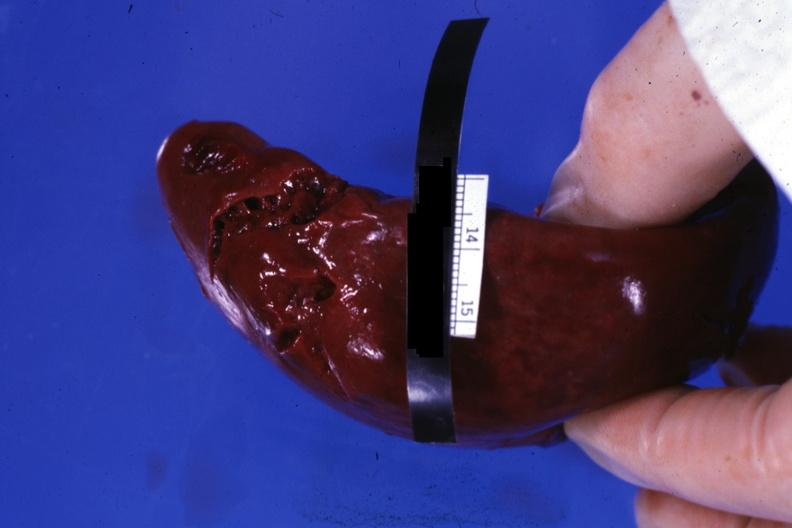s traumatic rupture present?
Answer the question using a single word or phrase. Yes 